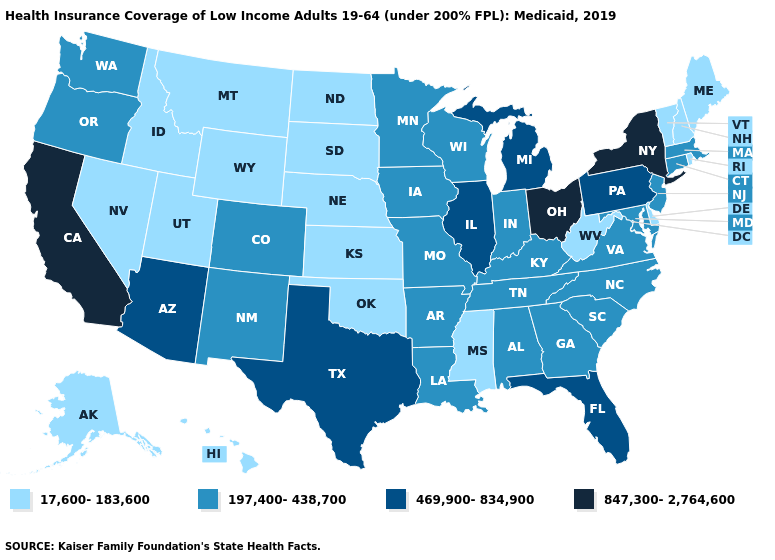Which states have the lowest value in the USA?
Write a very short answer. Alaska, Delaware, Hawaii, Idaho, Kansas, Maine, Mississippi, Montana, Nebraska, Nevada, New Hampshire, North Dakota, Oklahoma, Rhode Island, South Dakota, Utah, Vermont, West Virginia, Wyoming. What is the value of Hawaii?
Answer briefly. 17,600-183,600. Does the map have missing data?
Answer briefly. No. How many symbols are there in the legend?
Be succinct. 4. Does the map have missing data?
Quick response, please. No. What is the value of Florida?
Quick response, please. 469,900-834,900. What is the highest value in states that border Georgia?
Quick response, please. 469,900-834,900. What is the lowest value in the Northeast?
Give a very brief answer. 17,600-183,600. How many symbols are there in the legend?
Keep it brief. 4. Does Wisconsin have the lowest value in the USA?
Answer briefly. No. Does New Jersey have the highest value in the USA?
Keep it brief. No. Does the first symbol in the legend represent the smallest category?
Give a very brief answer. Yes. What is the value of Wisconsin?
Answer briefly. 197,400-438,700. What is the value of Texas?
Quick response, please. 469,900-834,900. 